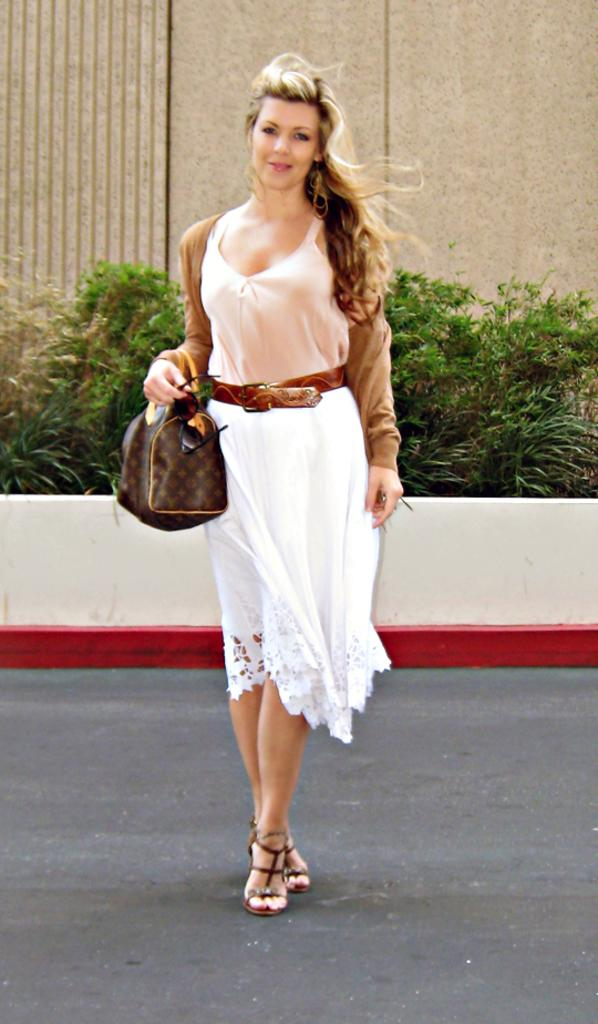What is the woman in the image doing? The woman is standing in the image. What is the woman holding in the image? The woman is holding a bag. What type of vegetation can be seen in the image? There are plants visible in the image. What is located behind the plants in the image? There is a wall behind the plants. What type of caption is written on the wall behind the plants? There is no caption visible on the wall behind the plants in the image. 